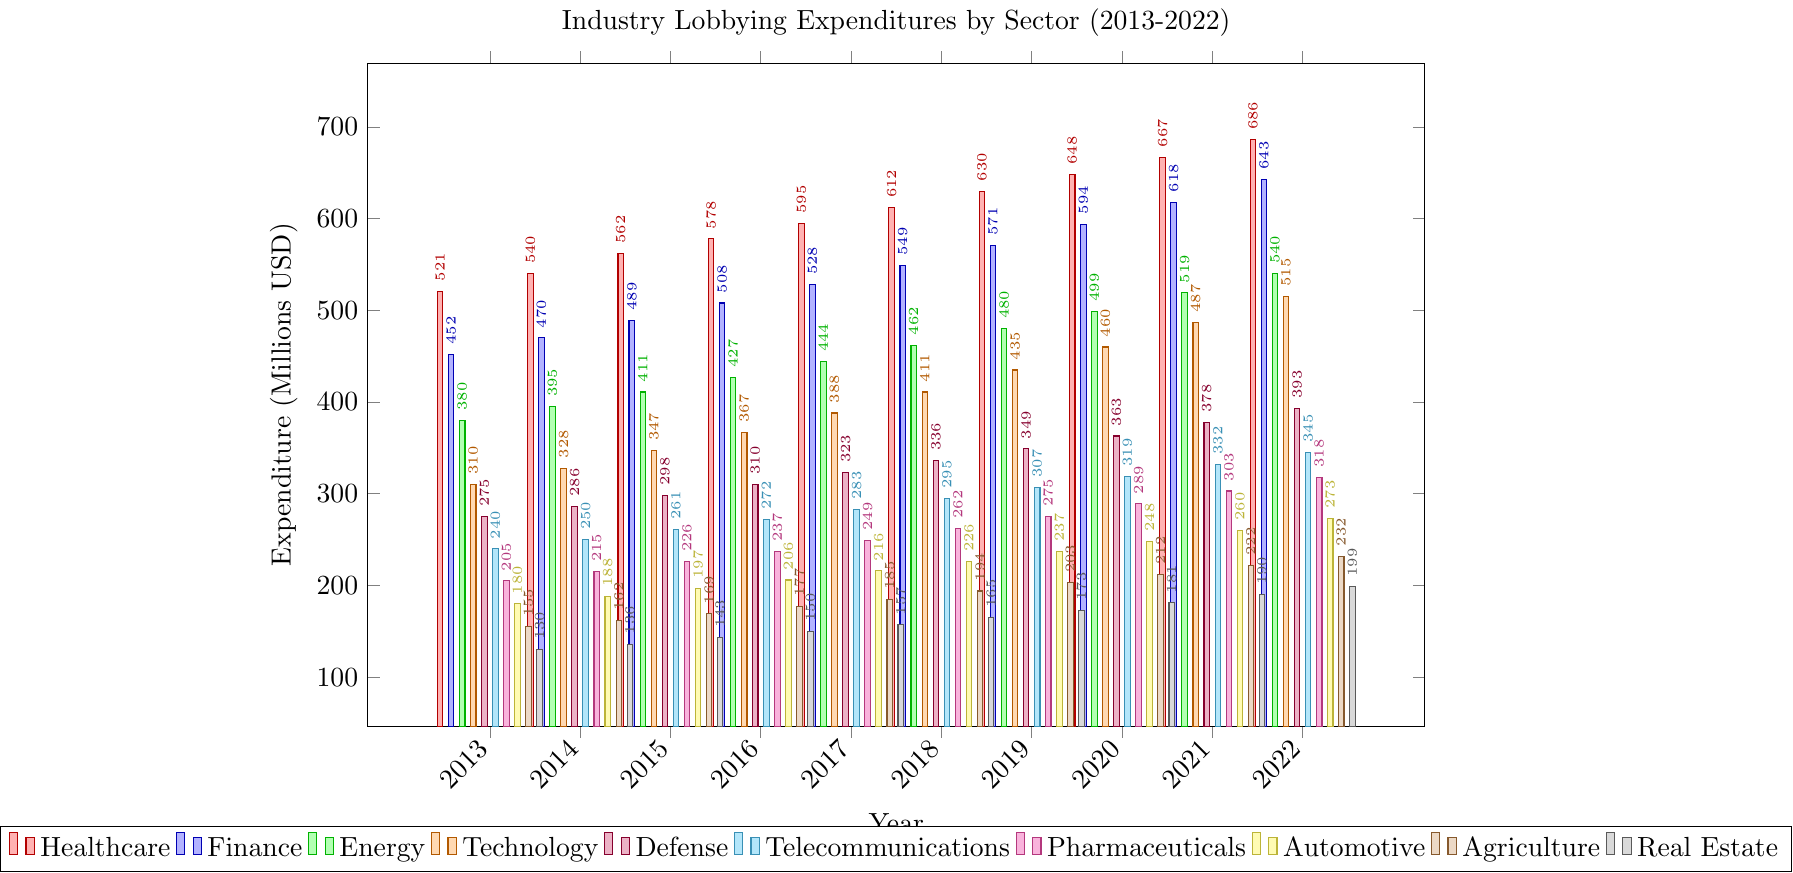Which sector had the highest lobbying expenditure in 2022? The highest bar in 2022 corresponds to Healthcare, indicating it had the highest expenditure.
Answer: Healthcare Which sector had the smallest increase in lobbying expenditure from 2013 to 2022? Calculate the difference for each sector between 2022 and 2013. Real Estate increased from 130 to 199, the smallest increase of 69 million USD.
Answer: Real Estate By how much did the lobbying expenditure for the Energy sector increase from 2013 to 2022? Subtract the 2013 value from the 2022 value for Energy: 540 - 380 = 160 million USD.
Answer: 160 million USD What was the average lobbying expenditure for the Technology sector over the decade? Sum the yearly expenditures for Technology from 2013 to 2022 and divide by 10: (310+328+347+367+388+411+435+460+487+515)/10 = 404.8 million USD.
Answer: 404.8 million USD Compare the lobbying expenditures of the Pharmaceuticals and Defense sectors in 2017. Which is higher and by how much? The Pharmaceuticals expenditure in 2017 is 249 and Defense is 323. The Defense sector is higher by 323 - 249 = 74 million USD.
Answer: Defense by 74 million USD Which sector had the steepest increase in lobbying expenditures between any two consecutive years? Identify the largest single-year increase for each sector and compare. The Healthcare sector increased by 95 (in 2021 to 2022), the steepest increase among all sectors.
Answer: Healthcare Which year had the largest combined total expenditure across all sectors? Sum the expenditures for each year and compare. The sums are highest in 2022: 686+643+540+515+393+345+318+273+232+199 = 4144 million USD.
Answer: 2022 After how many years did the Telecommunications sector surpass 300 million USD in lobbying expenditure? The Telecommunications sector crossed 300 million USD between 2019 (307 million USD) and 2020 (319 million USD). 2020 is 7 years after 2013.
Answer: After 7 years What's the total lobbying expenditure for the Agriculture sector over the decade? Sum the yearly expenditures for Agriculture from 2013 to 2022: 155+162+169+177+185+194+203+212+222+232 = 1911 million USD.
Answer: 1911 million USD How do the expenditures of the Healthcare and Finance sectors compare in 2020? Healthcare's expenditure in 2020 is 648 and Finance is 594. Healthcare's expenditure is higher by 648 - 594 = 54 million USD.
Answer: Healthcare by 54 million USD 